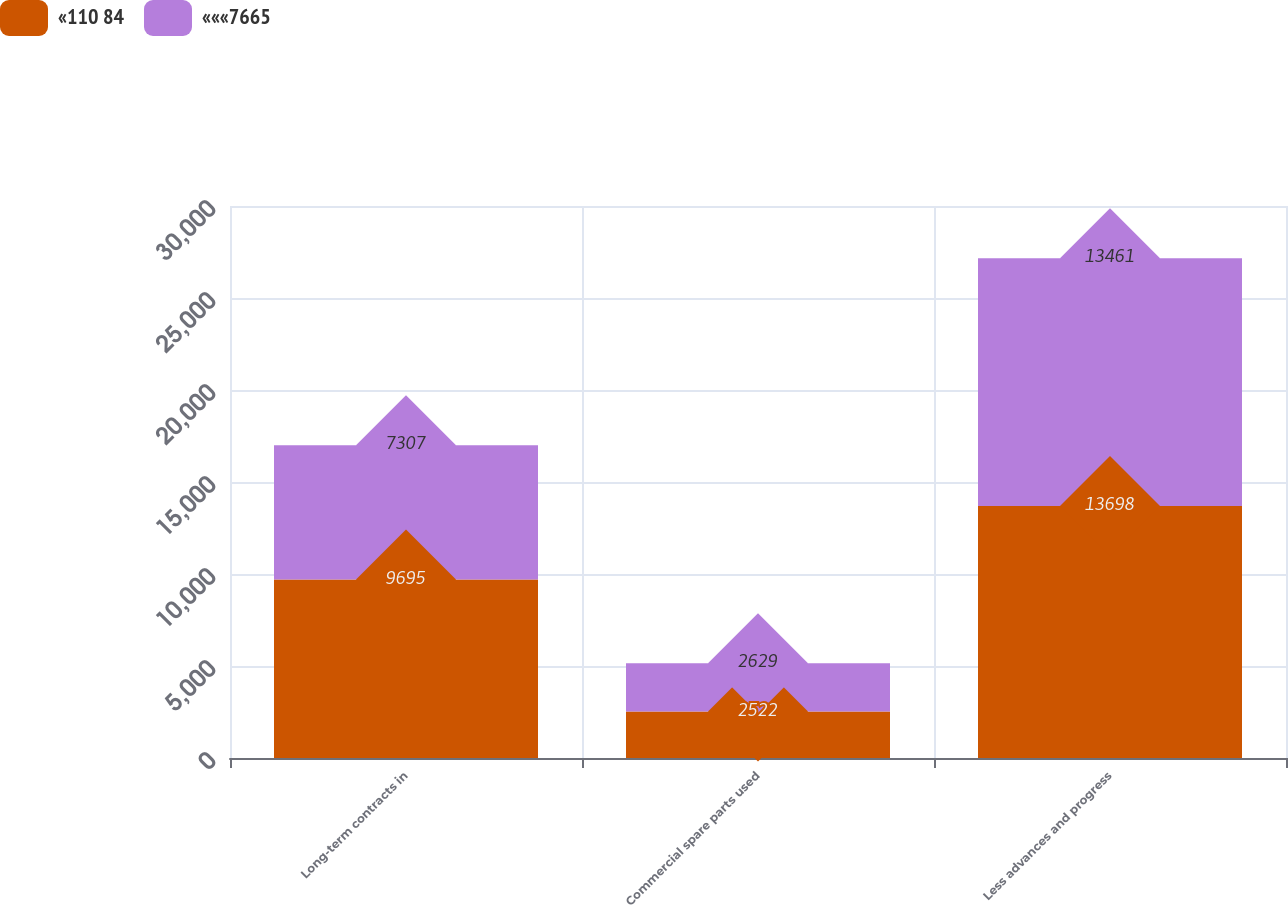<chart> <loc_0><loc_0><loc_500><loc_500><stacked_bar_chart><ecel><fcel>Long-term contracts in<fcel>Commercial spare parts used<fcel>Less advances and progress<nl><fcel>«110 84<fcel>9695<fcel>2522<fcel>13698<nl><fcel>«««7665<fcel>7307<fcel>2629<fcel>13461<nl></chart> 